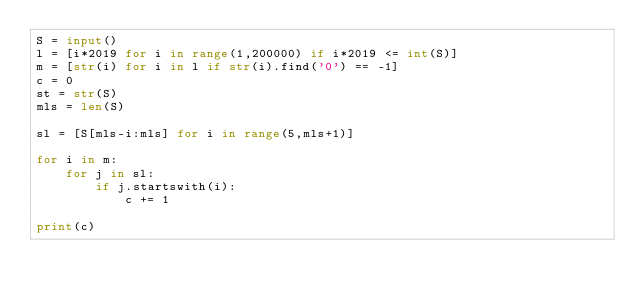<code> <loc_0><loc_0><loc_500><loc_500><_Python_>S = input()
l = [i*2019 for i in range(1,200000) if i*2019 <= int(S)]
m = [str(i) for i in l if str(i).find('0') == -1]
c = 0
st = str(S)
mls = len(S)

sl = [S[mls-i:mls] for i in range(5,mls+1)]

for i in m:
    for j in sl:
        if j.startswith(i):
            c += 1

print(c)</code> 